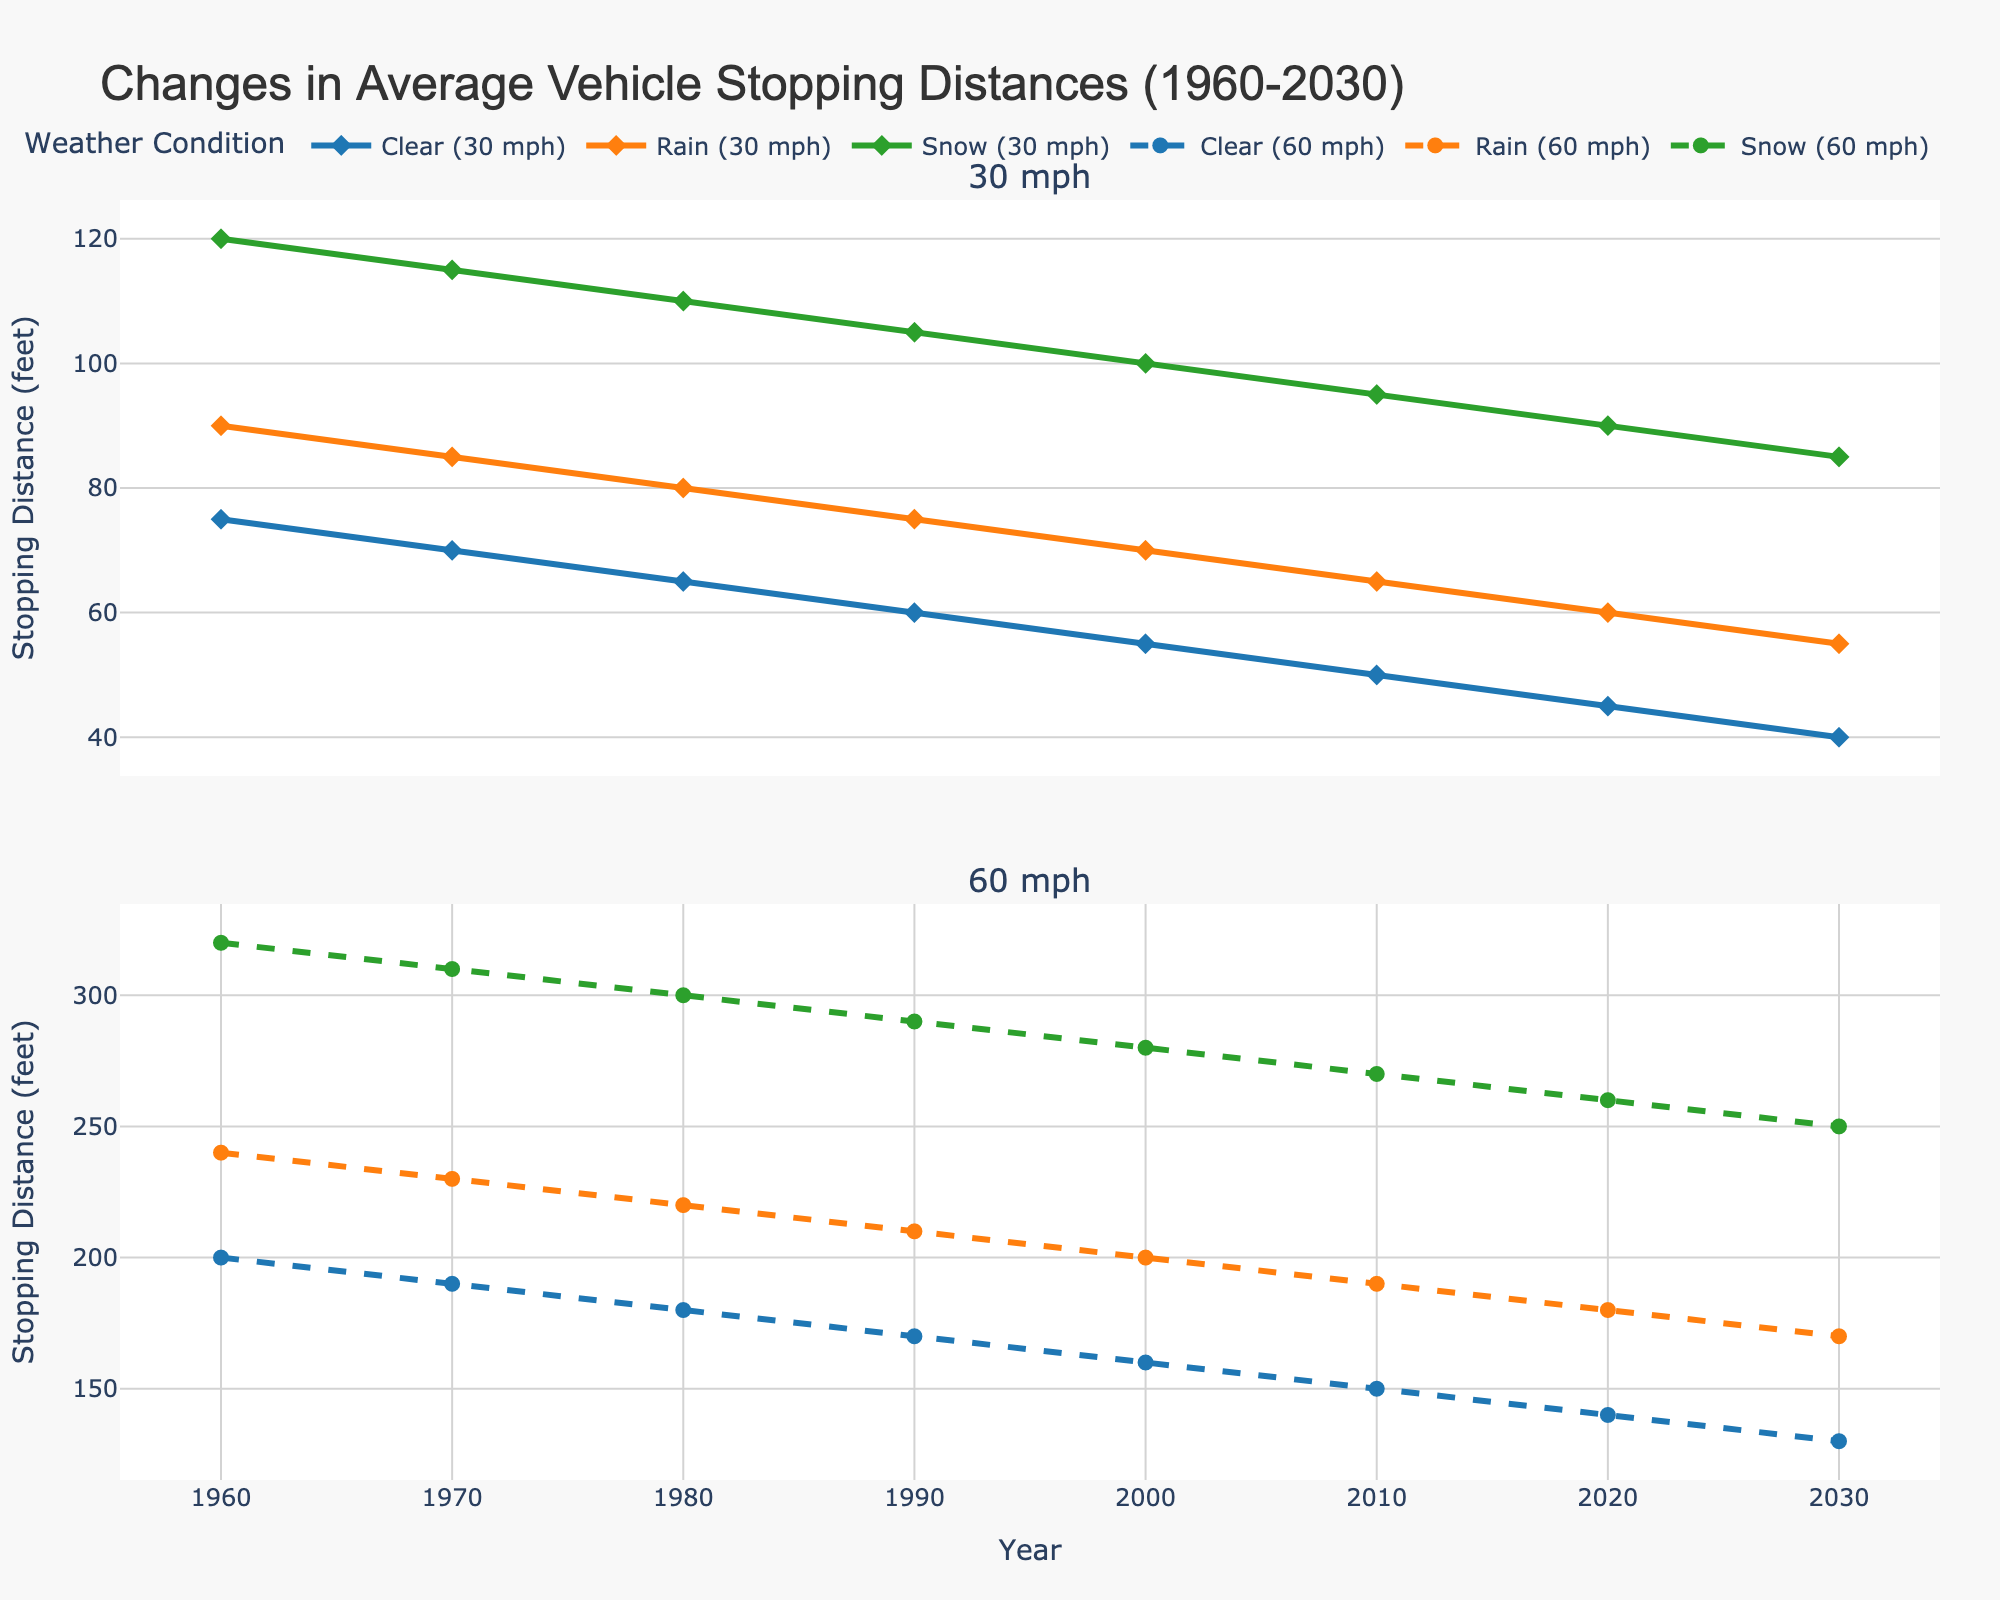What is the stopping distance for a car driving at 30 mph in clear weather in 1960? Look at the plot for 30 mph speeds under clear weather conditions and identify the stopping distance value for the year 1960
Answer: 75 feet Which weather condition showed the greatest reduction in stopping distance for 60 mph from 1960 to 2030? Compare the reduction in stopping distances for all three weather conditions (Clear, Rain, Snow) for 60 mph between 1960 and 2030. Calculate the difference for each: Clear (200-130), Rain (240-170), Snow (320-250). The condition with the highest difference is the greatest reduction
Answer: Snow (70 feet) What is the total change in stopping distance from 1960 to 2030 for a car traveling 30 mph in rain and snow? Calculate the change for rain and snow individually: Rain (90-55), Snow (120-85). Add these two values together for the total change
Answer: 70 feet Between which two decades did the stopping distance for cars traveling 30 mph in clear weather decrease the most? Identify the stopping distances for each decade (1960, 1970, ..., 2030) under clear weather for 30 mph, then calculate the difference between successive decades. The largest difference indicates the greatest decrease
Answer: 1980 and 1990 (5 feet) In 2010, how much further did a car need to stop when traveling at 60 mph in snow compared to rain? Look at the plot for 60 mph speeds in 2010 and identify the stopping distances for snow and rain. Subtract the rain stopping distance from the snow stopping distance to find the difference
Answer: 80 feet How does the stopping distance trend for 30 mph under snow conditions compare to the trend for clear conditions? Observe the general trend of the lines for snow and clear conditions at 30 mph. Both lines show a decreasing trend over time, but snow starts higher and decreases at a similar rate
Answer: Both decrease, snow starts higher What is the average stopping distance for clear conditions at 60 mph from 1960 to 2030? Sum the stopping distance values at 60 mph under clear conditions for each decade (200, 190, 180, 170, 160, 150, 140, 130), then divide by the number of decades (8) to find the average
Answer: 165 feet By how much did the stopping distance decrease for 30 mph clear weather from 1980 to 2020? Identify the stopping distances for 30 mph clear weather in 1980 and 2020 (65 and 45 respectively). Subtract the value for 2020 from that of 1980
Answer: 20 feet In what year did the stopping distance for 30 mph in rain first fall below 70 feet? Look at the plot for rain conditions at 30 mph and identify the first year where the stopping distance is below 70 feet
Answer: 2000 Compare the stopping distance trends for 60 mph in clear and rain conditions. Which condition shows a steeper decline? Observe the slopes of the lines for 60 mph clear and rain conditions. Both lines show a decreasing trend, but the rain condition line appears to have a steeper slope
Answer: Rain shows a steeper decline 